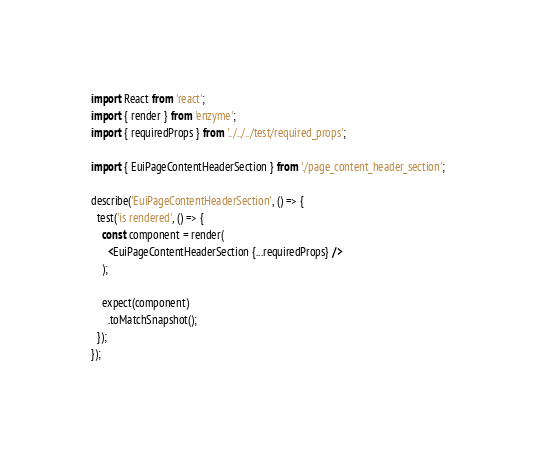Convert code to text. <code><loc_0><loc_0><loc_500><loc_500><_JavaScript_>import React from 'react';
import { render } from 'enzyme';
import { requiredProps } from '../../../test/required_props';

import { EuiPageContentHeaderSection } from './page_content_header_section';

describe('EuiPageContentHeaderSection', () => {
  test('is rendered', () => {
    const component = render(
      <EuiPageContentHeaderSection {...requiredProps} />
    );

    expect(component)
      .toMatchSnapshot();
  });
});
</code> 